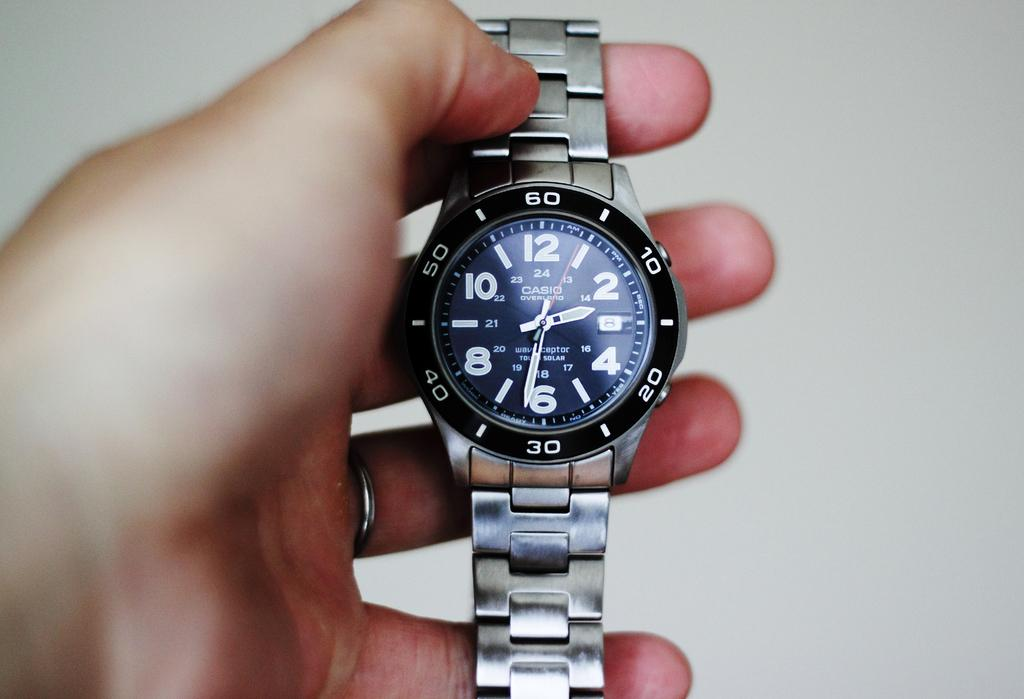<image>
Provide a brief description of the given image. A person is holding a silver metal Casio watch. 